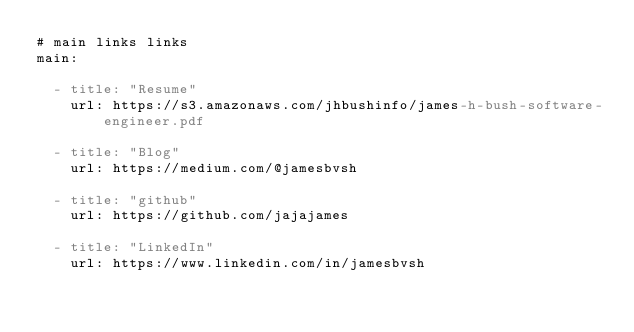<code> <loc_0><loc_0><loc_500><loc_500><_YAML_># main links links
main:

  - title: "Resume"
    url: https://s3.amazonaws.com/jhbushinfo/james-h-bush-software-engineer.pdf

  - title: "Blog"
    url: https://medium.com/@jamesbvsh

  - title: "github"
    url: https://github.com/jajajames

  - title: "LinkedIn"
    url: https://www.linkedin.com/in/jamesbvsh
</code> 